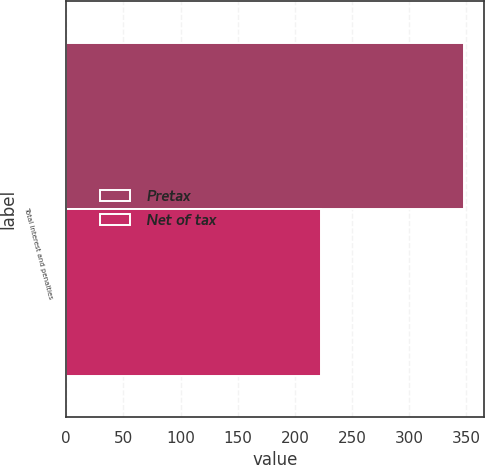<chart> <loc_0><loc_0><loc_500><loc_500><stacked_bar_chart><ecel><fcel>Total interest and penalties<nl><fcel>Pretax<fcel>348<nl><fcel>Net of tax<fcel>223<nl></chart> 